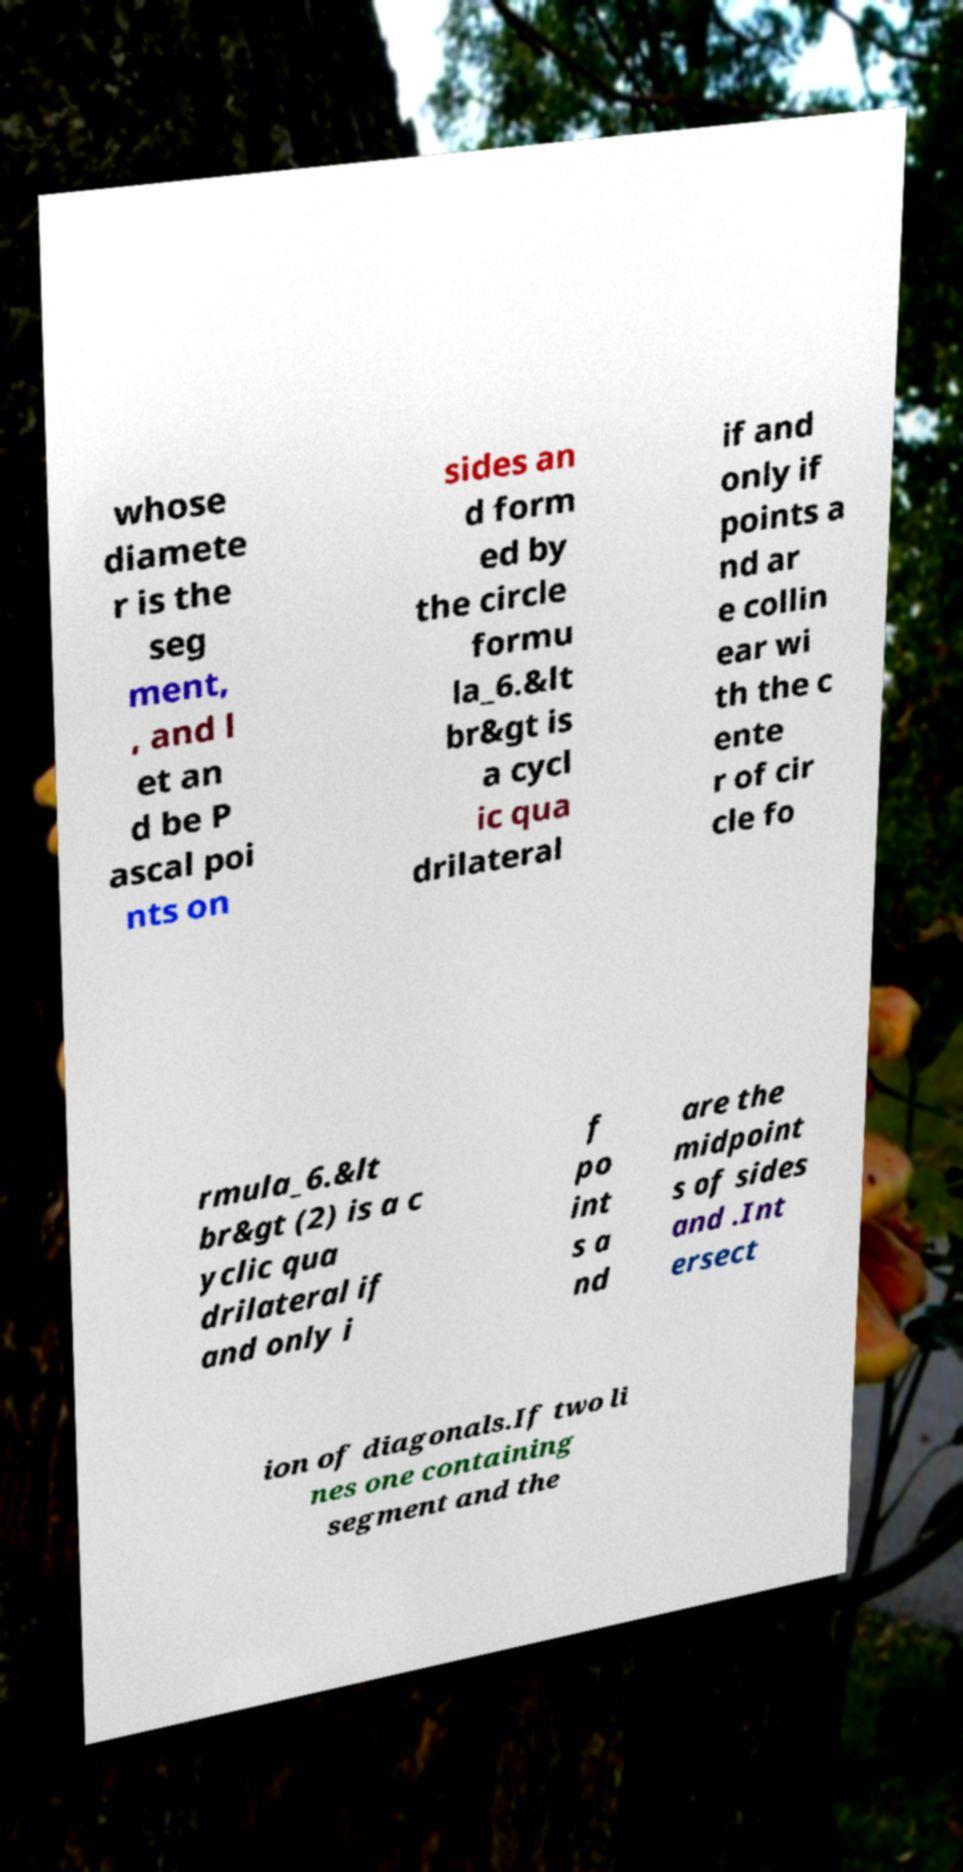Could you extract and type out the text from this image? whose diamete r is the seg ment, , and l et an d be P ascal poi nts on sides an d form ed by the circle formu la_6.&lt br&gt is a cycl ic qua drilateral if and only if points a nd ar e collin ear wi th the c ente r of cir cle fo rmula_6.&lt br&gt (2) is a c yclic qua drilateral if and only i f po int s a nd are the midpoint s of sides and .Int ersect ion of diagonals.If two li nes one containing segment and the 